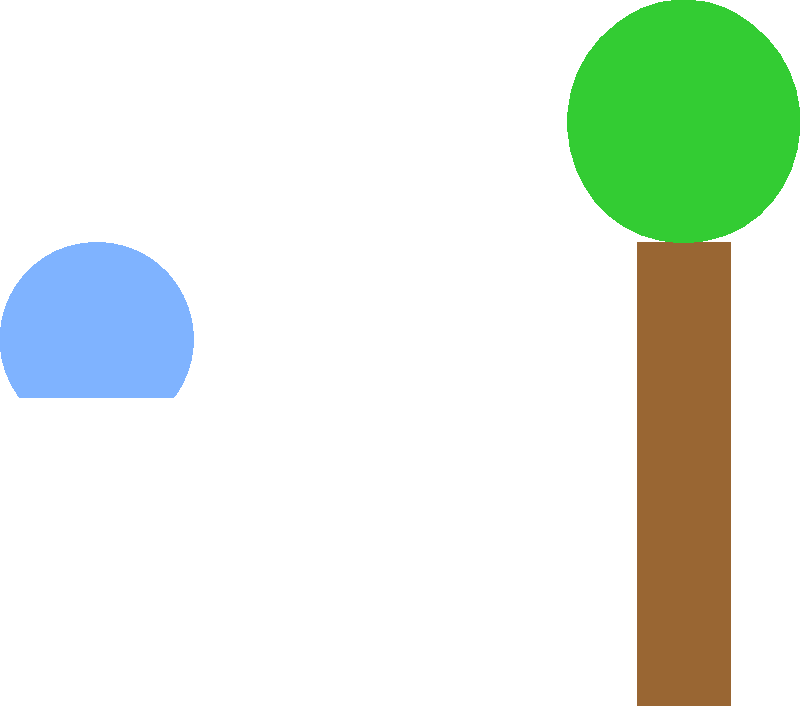Based on the infographic, which environmental impact of lithium mining for EV batteries is shown to be more significant, and how might this challenge Elon Musk's claims about Tesla's environmental benefits? To answer this question, let's analyze the infographic step-by-step:

1. The infographic shows two main environmental impacts of lithium mining: water usage and CO2 emissions.

2. The bar chart at the bottom compares these two impacts:
   - Water usage bar is longer, reaching about 50 units on the scale.
   - CO2 emissions bar is shorter, reaching about 30 units on the scale.

3. This visual representation indicates that water usage is the more significant environmental impact of lithium mining for EV batteries.

4. The water droplet icon at the top left of the infographic further emphasizes the importance of water in this process.

5. Elon Musk often touts Tesla's EVs as environmentally friendly alternatives to conventional vehicles. However, this data challenges that narrative by highlighting the substantial water consumption in lithium mining.

6. As a technology journalist questioning Musk's motives and actions, you might consider how this water usage impact:
   - Affects water-scarce regions where lithium is often mined.
   - Compares to the water usage of traditional vehicle manufacturing.
   - Balances against the long-term environmental benefits of EVs.

7. This information could be used to argue that while EVs may reduce CO2 emissions during operation, their production process still has significant environmental impacts that Musk and Tesla may be downplaying.
Answer: Water usage, challenging Tesla's overall environmental benefit claims. 